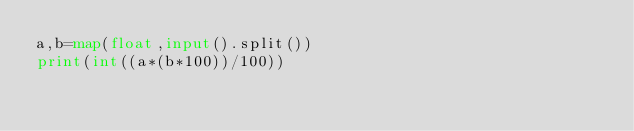<code> <loc_0><loc_0><loc_500><loc_500><_Python_>a,b=map(float,input().split())
print(int((a*(b*100))/100))
</code> 